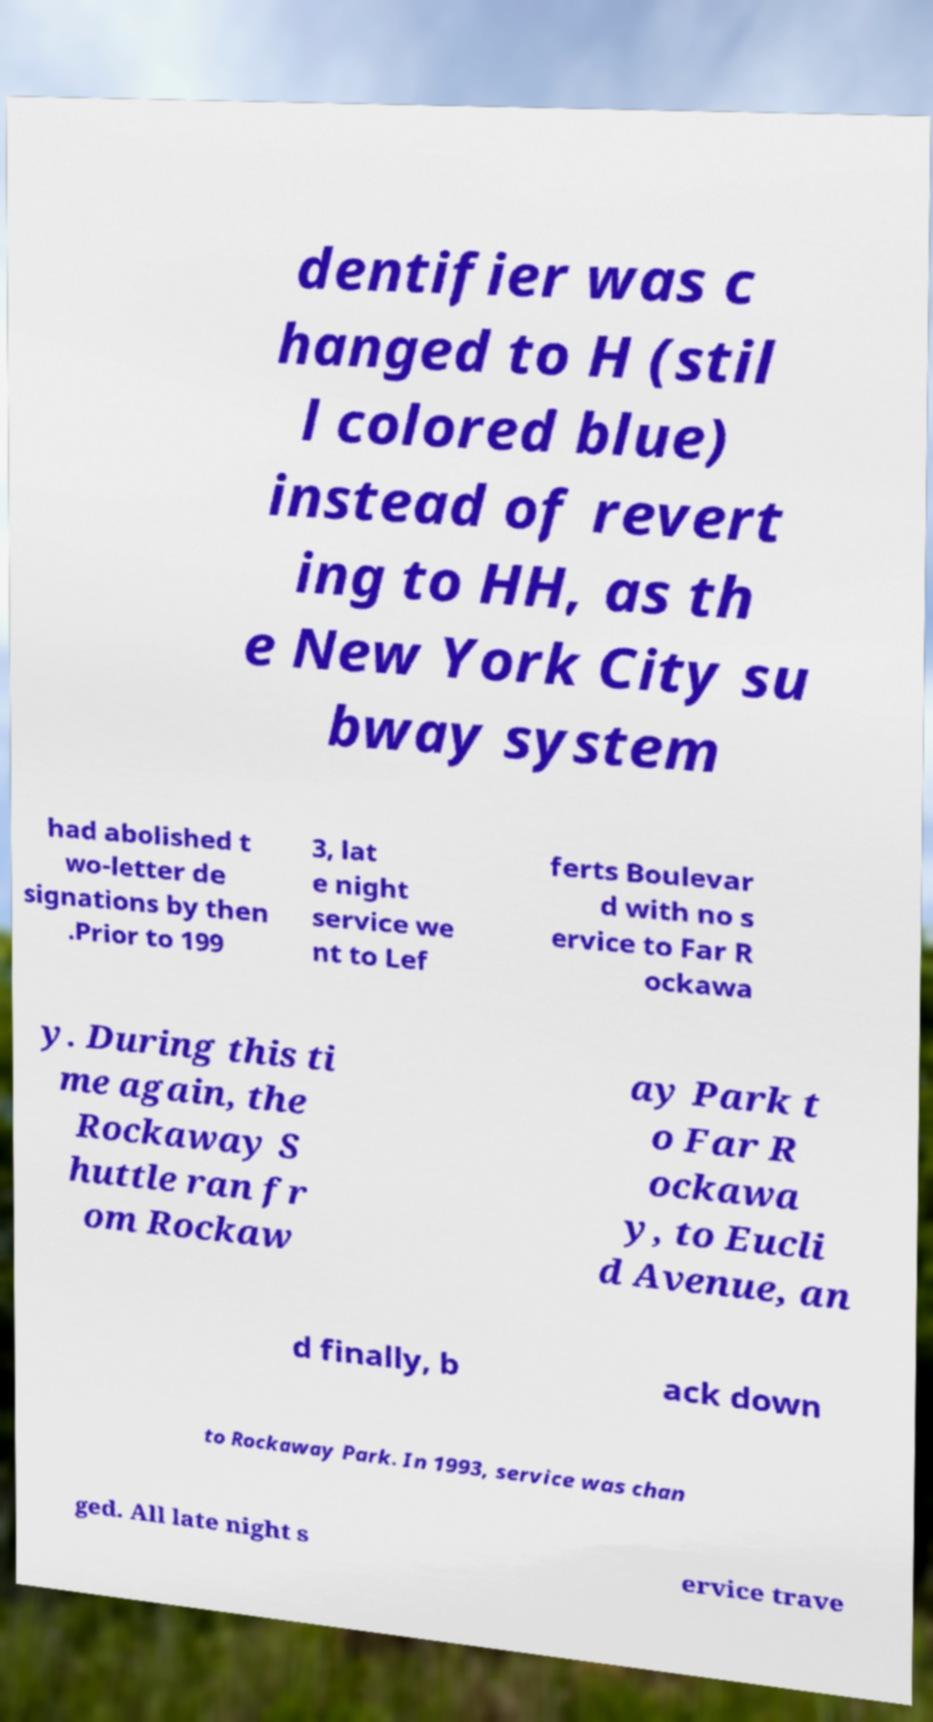Could you assist in decoding the text presented in this image and type it out clearly? dentifier was c hanged to H (stil l colored blue) instead of revert ing to HH, as th e New York City su bway system had abolished t wo-letter de signations by then .Prior to 199 3, lat e night service we nt to Lef ferts Boulevar d with no s ervice to Far R ockawa y. During this ti me again, the Rockaway S huttle ran fr om Rockaw ay Park t o Far R ockawa y, to Eucli d Avenue, an d finally, b ack down to Rockaway Park. In 1993, service was chan ged. All late night s ervice trave 